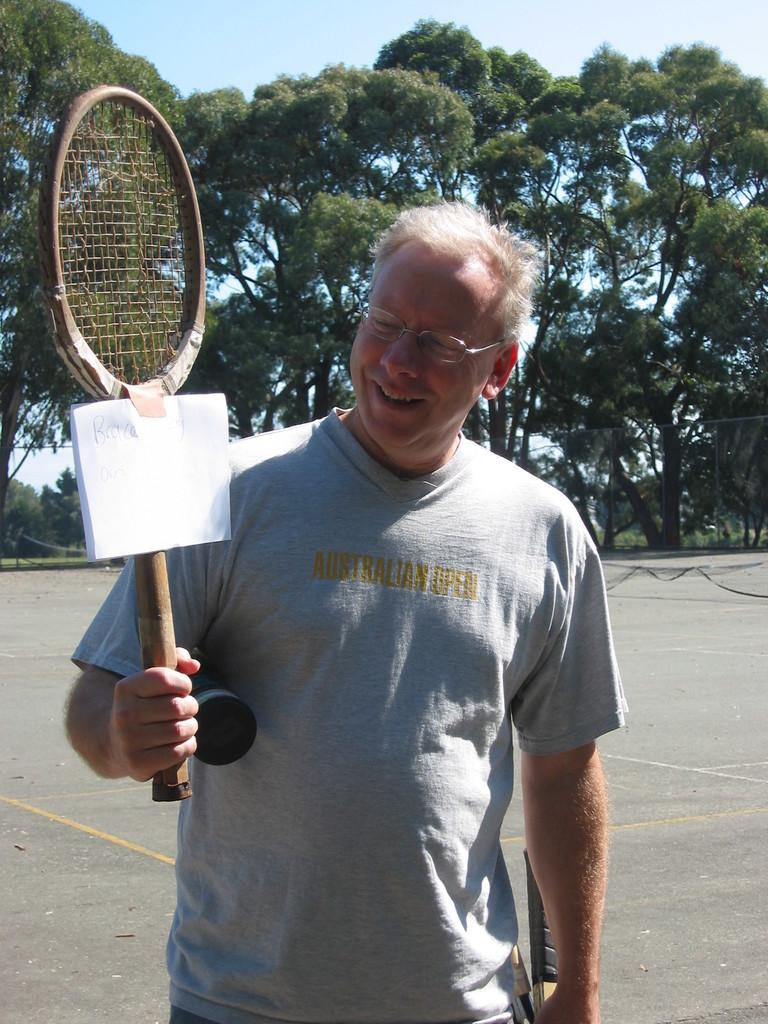Who or what is present in the image? There is a person in the image. What is the person wearing? The person is wearing clothes. What object is the person holding? The person is holding a tennis racket. What can be seen in the middle of the image? There are trees in the middle of the image. What type of brick is being used to construct the committee in the image? There is no committee or brick present in the image. 